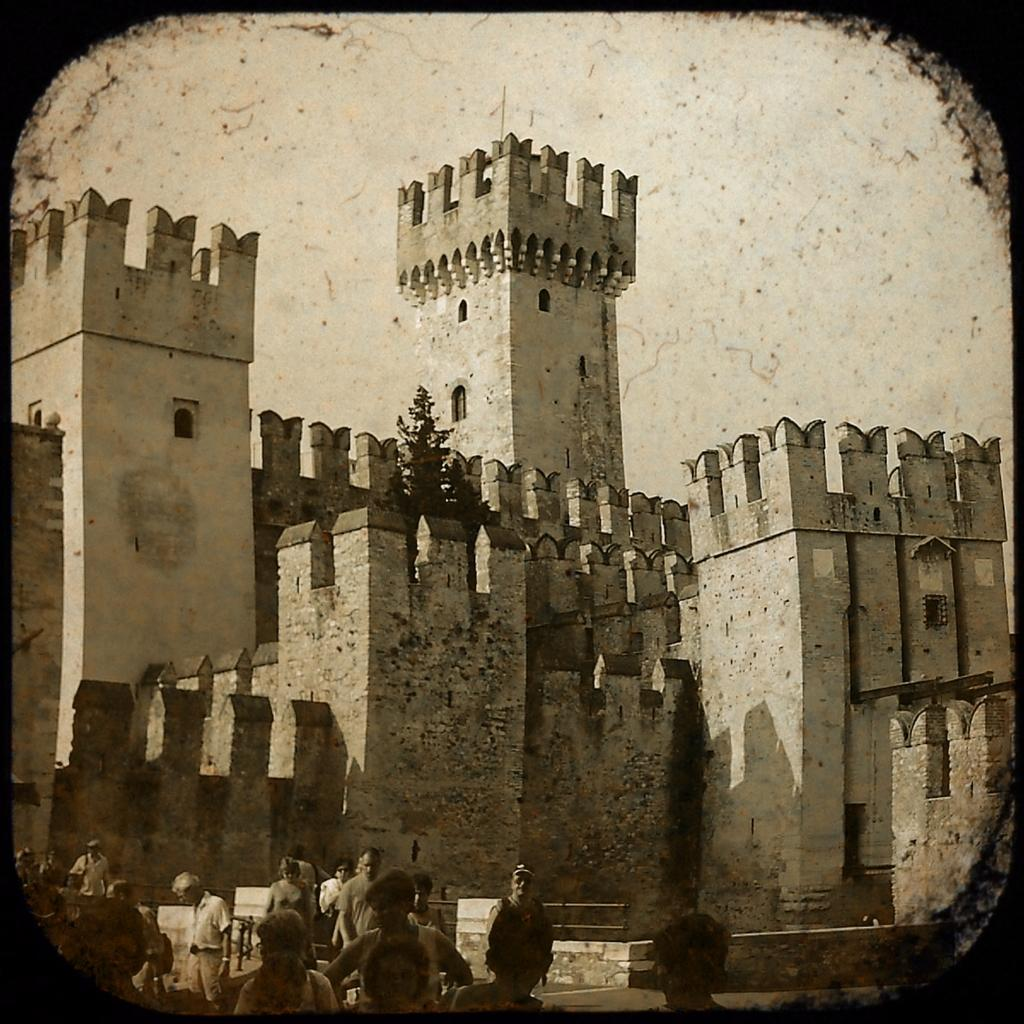What is the main structure in the center of the image? There is a castle in the center of the image. Can you describe the people at the bottom of the image? The people are at the bottom of the image, but their specific actions or characteristics are not mentioned in the facts. What can be seen in the background of the image? The sky is visible in the background of the image. How many chairs are placed around the bun in the image? There is no mention of chairs or a bun in the image; the facts only mention a castle, people, and the sky. 